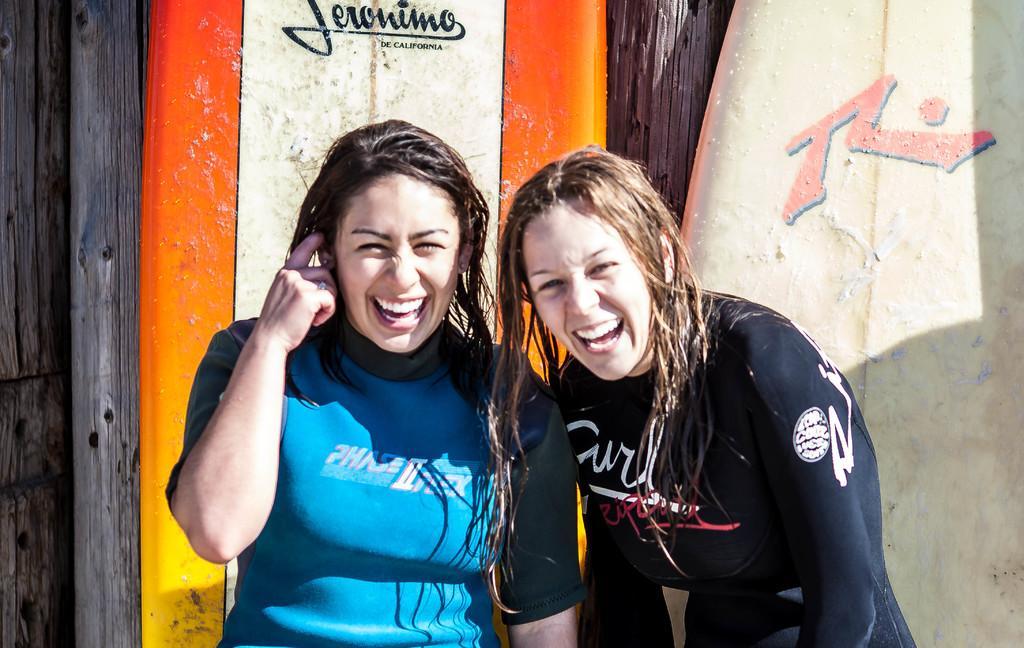Describe this image in one or two sentences. In this picture we can see two women, they are smiling and in the background we can see surfboards, wooden poles. 